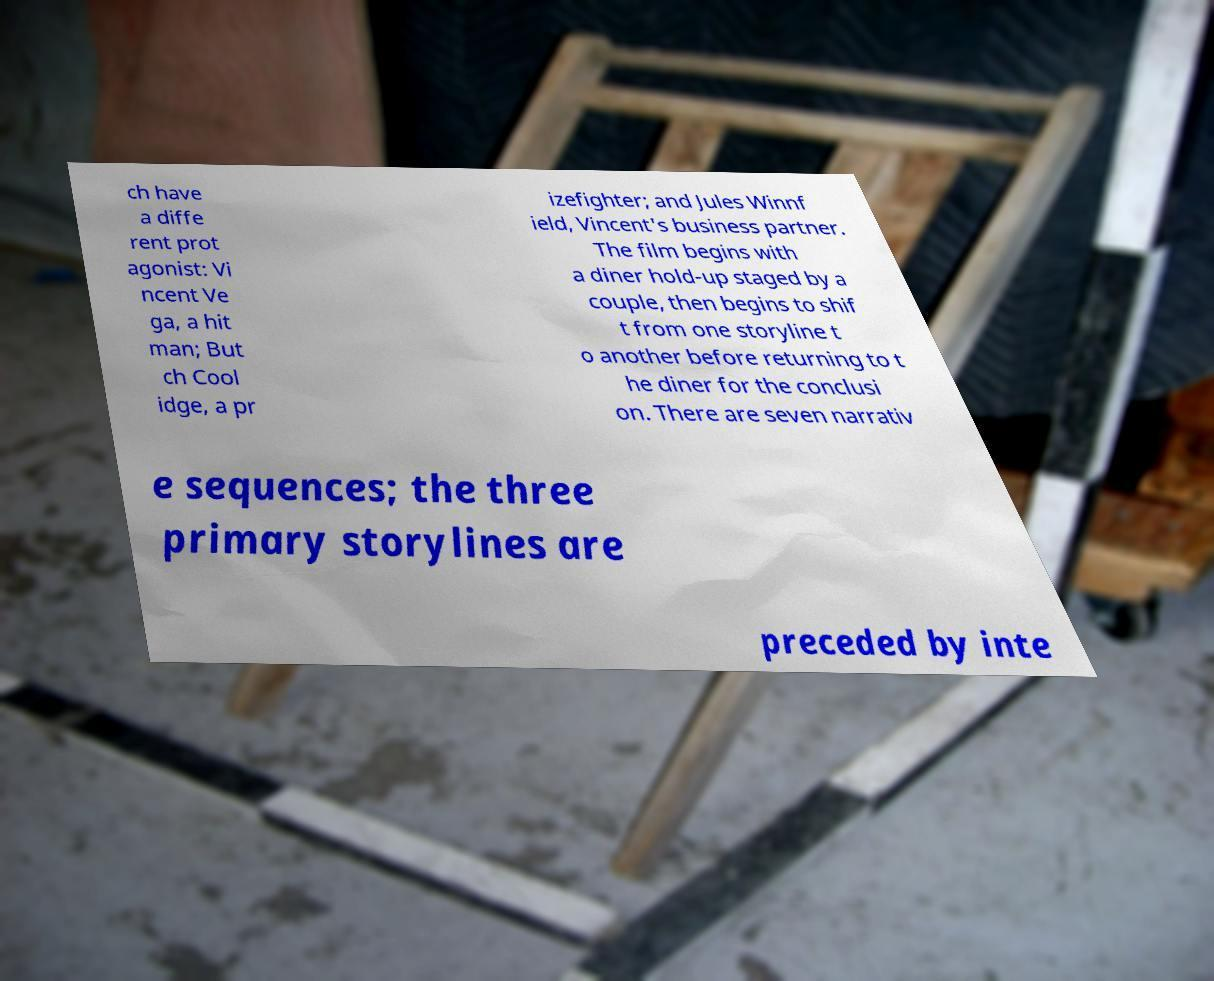Please read and relay the text visible in this image. What does it say? ch have a diffe rent prot agonist: Vi ncent Ve ga, a hit man; But ch Cool idge, a pr izefighter; and Jules Winnf ield, Vincent's business partner. The film begins with a diner hold-up staged by a couple, then begins to shif t from one storyline t o another before returning to t he diner for the conclusi on. There are seven narrativ e sequences; the three primary storylines are preceded by inte 